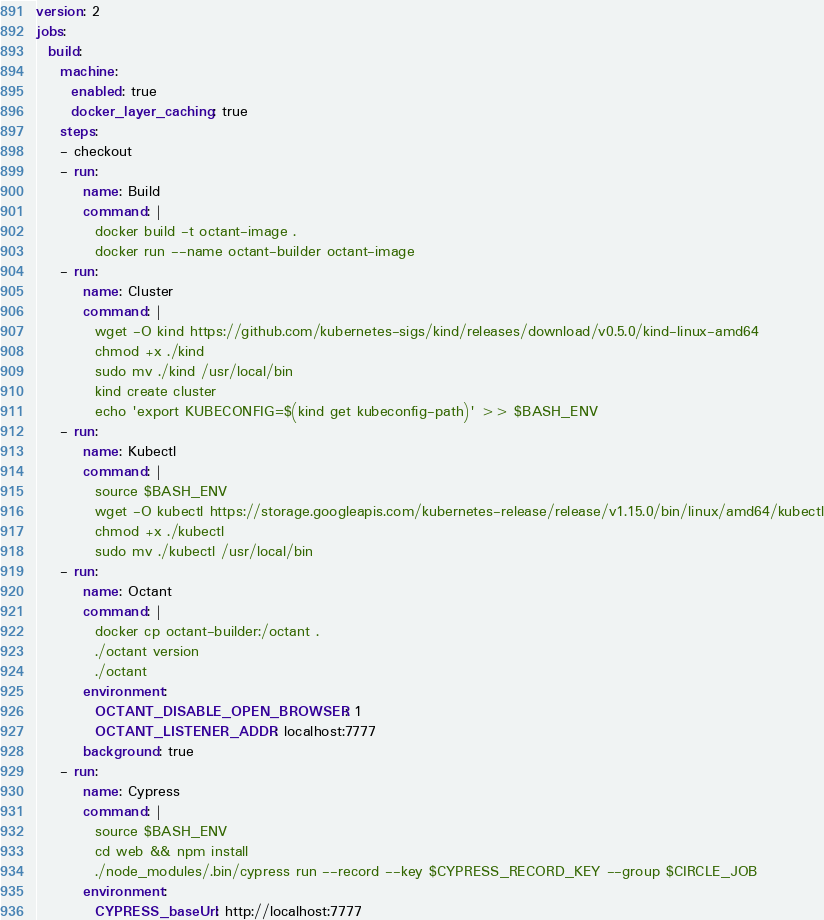Convert code to text. <code><loc_0><loc_0><loc_500><loc_500><_YAML_>version: 2
jobs:
  build:
    machine:
      enabled: true
      docker_layer_caching: true 
    steps:
    - checkout
    - run:
        name: Build
        command: |
          docker build -t octant-image .
          docker run --name octant-builder octant-image
    - run:
        name: Cluster
        command: |
          wget -O kind https://github.com/kubernetes-sigs/kind/releases/download/v0.5.0/kind-linux-amd64
          chmod +x ./kind
          sudo mv ./kind /usr/local/bin
          kind create cluster
          echo 'export KUBECONFIG=$(kind get kubeconfig-path)' >> $BASH_ENV
    - run:
        name: Kubectl
        command: |
          source $BASH_ENV
          wget -O kubectl https://storage.googleapis.com/kubernetes-release/release/v1.15.0/bin/linux/amd64/kubectl
          chmod +x ./kubectl
          sudo mv ./kubectl /usr/local/bin
    - run:
        name: Octant
        command: |
          docker cp octant-builder:/octant .
          ./octant version
          ./octant
        environment:
          OCTANT_DISABLE_OPEN_BROWSER: 1
          OCTANT_LISTENER_ADDR: localhost:7777
        background: true
    - run:
        name: Cypress
        command: |
          source $BASH_ENV
          cd web && npm install
          ./node_modules/.bin/cypress run --record --key $CYPRESS_RECORD_KEY --group $CIRCLE_JOB
        environment:
          CYPRESS_baseUrl: http://localhost:7777
</code> 